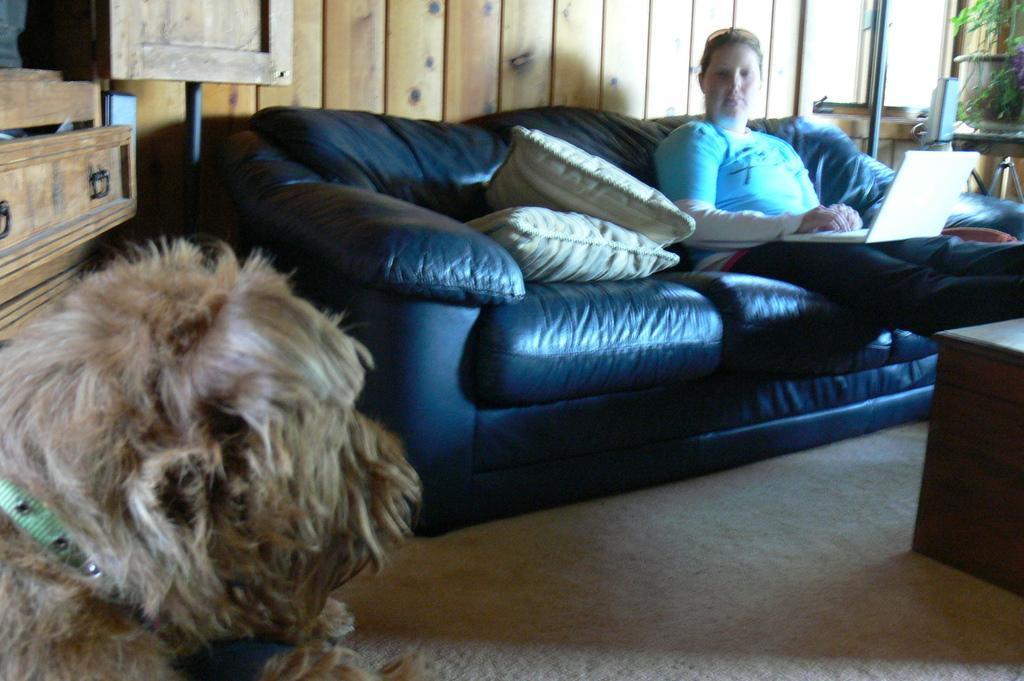Please provide a concise description of this image. In this image i can see a woman is sitting on a couch. I can also there is a dog, a table and couple of pillows on the couch. 